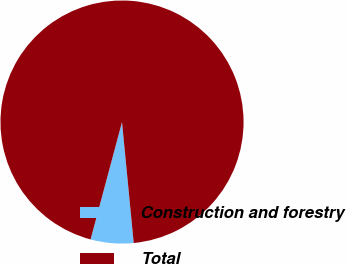Convert chart to OTSL. <chart><loc_0><loc_0><loc_500><loc_500><pie_chart><fcel>Construction and forestry<fcel>Total<nl><fcel>5.7%<fcel>94.3%<nl></chart> 